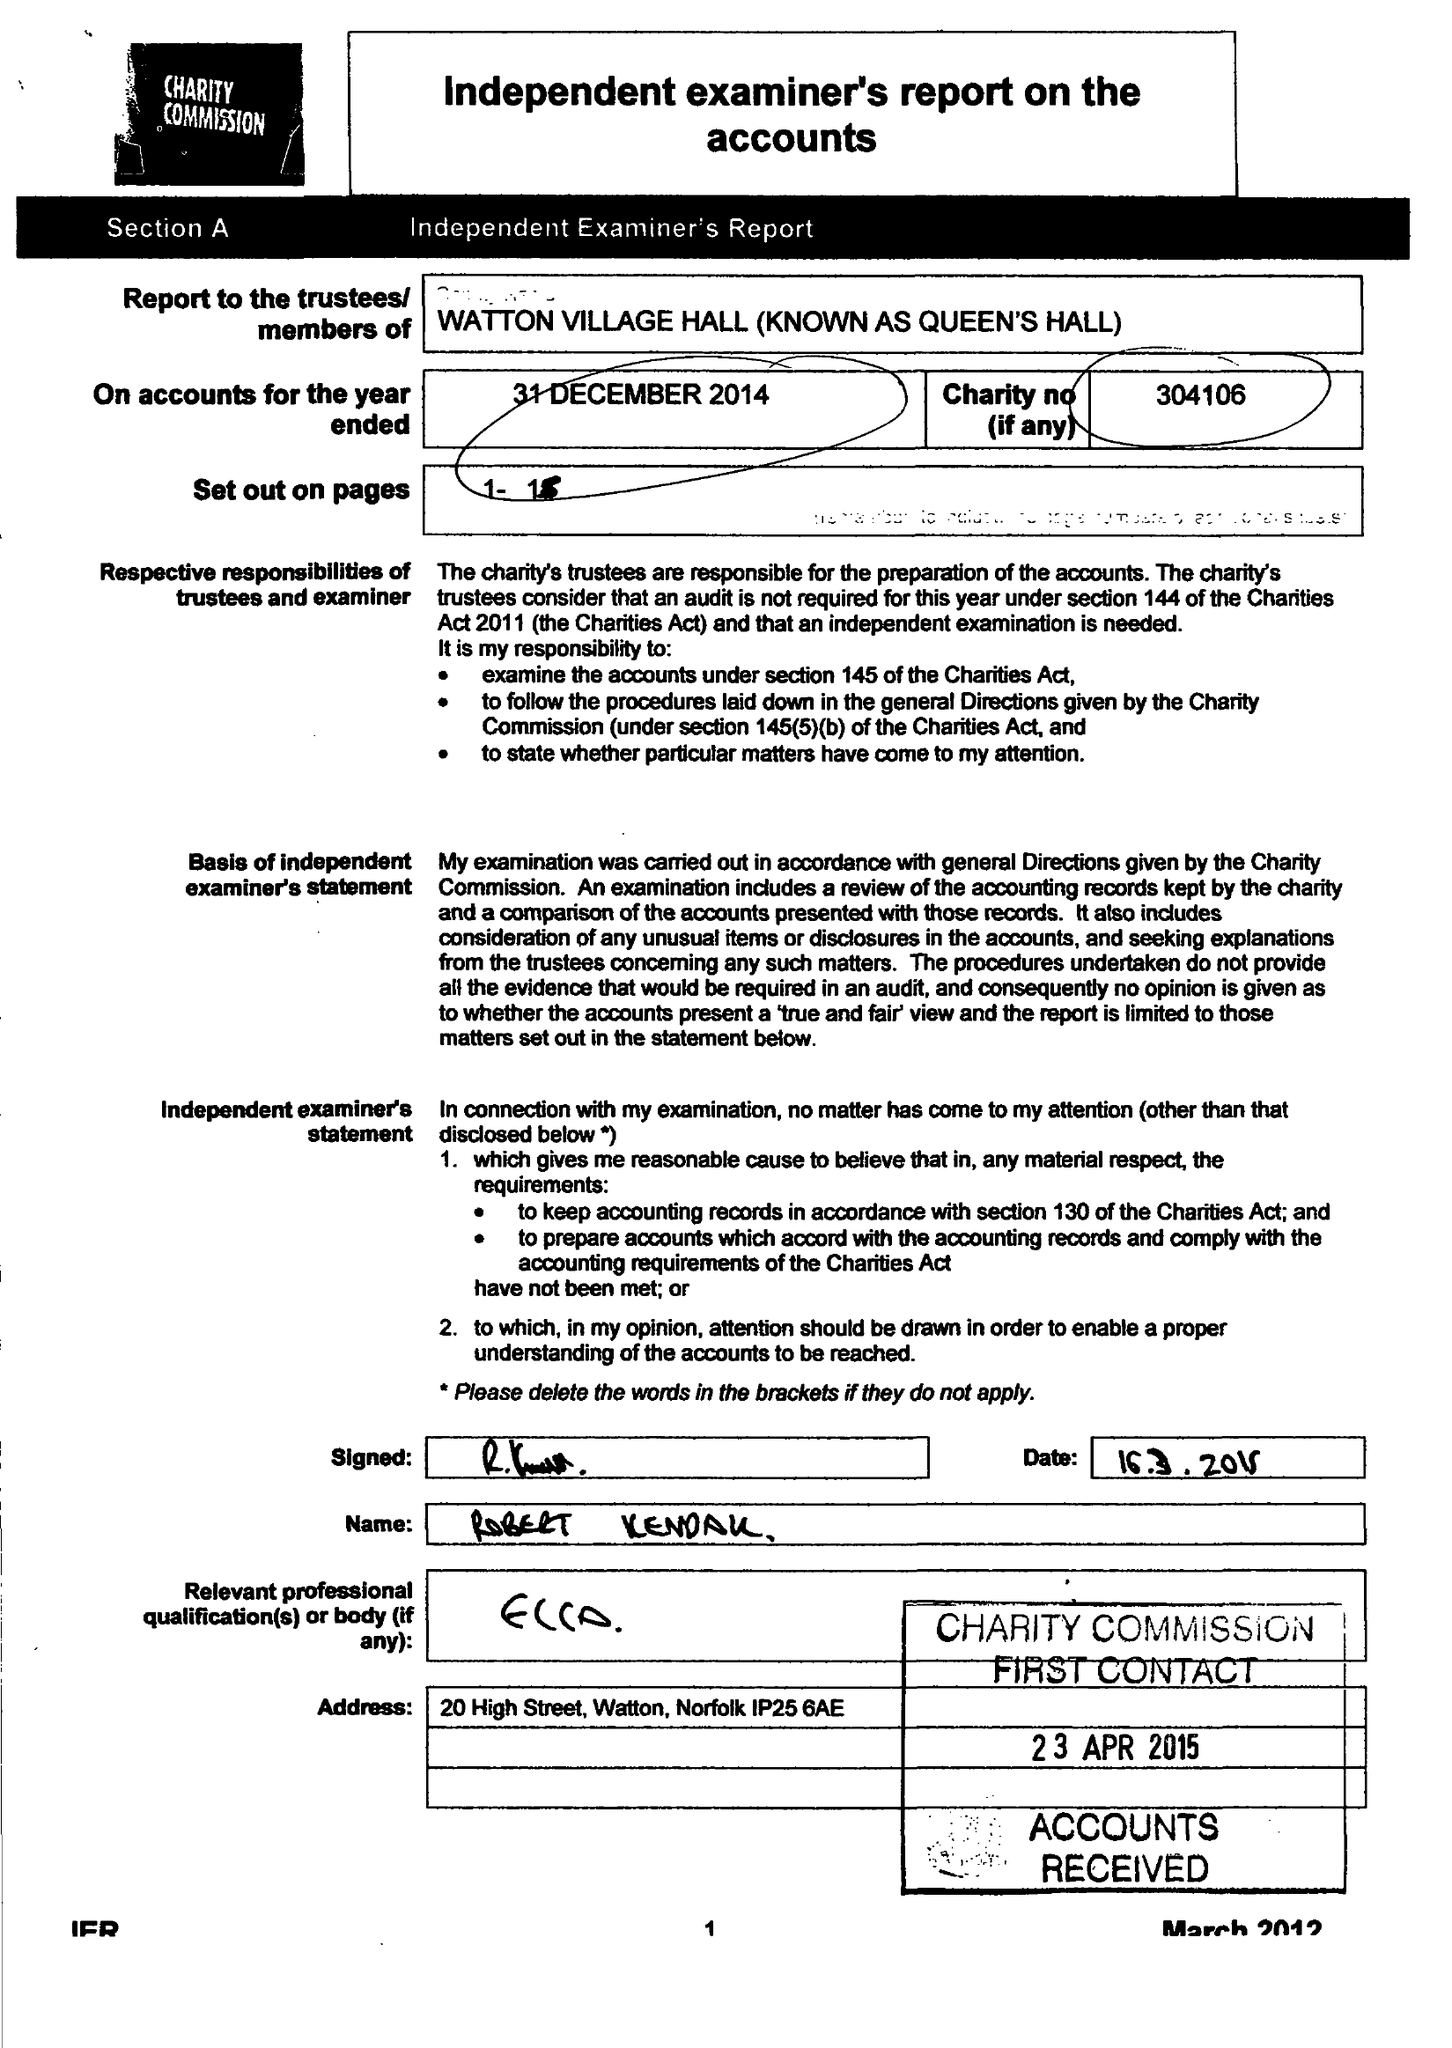What is the value for the spending_annually_in_british_pounds?
Answer the question using a single word or phrase. 34300.00 